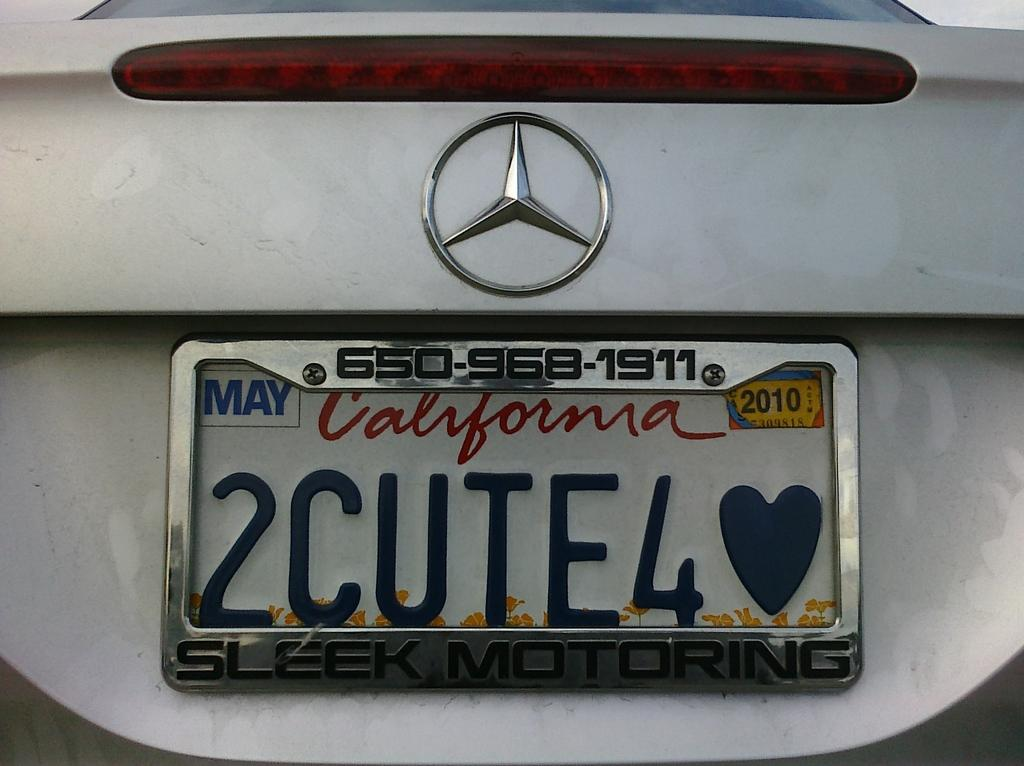<image>
Provide a brief description of the given image. A white mercedes has a license plate from California on it. 